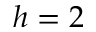<formula> <loc_0><loc_0><loc_500><loc_500>h = 2</formula> 